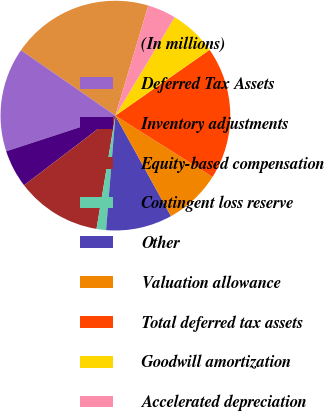Convert chart to OTSL. <chart><loc_0><loc_0><loc_500><loc_500><pie_chart><fcel>(In millions)<fcel>Deferred Tax Assets<fcel>Inventory adjustments<fcel>Equity-based compensation<fcel>Contingent loss reserve<fcel>Other<fcel>Valuation allowance<fcel>Total deferred tax assets<fcel>Goodwill amortization<fcel>Accelerated depreciation<nl><fcel>19.99%<fcel>14.66%<fcel>5.34%<fcel>12.0%<fcel>1.34%<fcel>9.33%<fcel>8.0%<fcel>18.66%<fcel>6.67%<fcel>4.01%<nl></chart> 